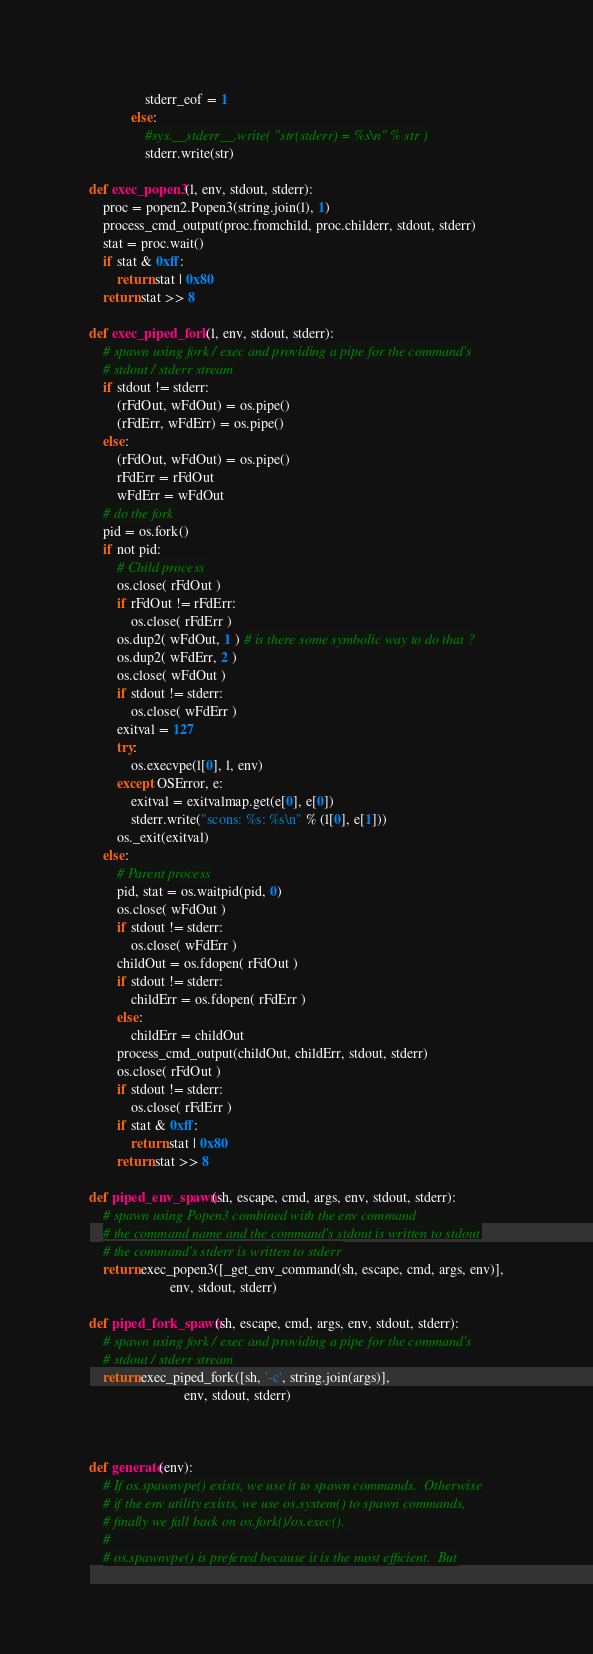<code> <loc_0><loc_0><loc_500><loc_500><_Python_>                stderr_eof = 1
            else:
                #sys.__stderr__.write( "str(stderr) = %s\n" % str )
                stderr.write(str)

def exec_popen3(l, env, stdout, stderr):
    proc = popen2.Popen3(string.join(l), 1)
    process_cmd_output(proc.fromchild, proc.childerr, stdout, stderr)
    stat = proc.wait()
    if stat & 0xff:
        return stat | 0x80
    return stat >> 8

def exec_piped_fork(l, env, stdout, stderr):
    # spawn using fork / exec and providing a pipe for the command's
    # stdout / stderr stream
    if stdout != stderr:
        (rFdOut, wFdOut) = os.pipe()
        (rFdErr, wFdErr) = os.pipe()
    else:
        (rFdOut, wFdOut) = os.pipe()
        rFdErr = rFdOut
        wFdErr = wFdOut
    # do the fork
    pid = os.fork()
    if not pid:
        # Child process
        os.close( rFdOut )
        if rFdOut != rFdErr:
            os.close( rFdErr )
        os.dup2( wFdOut, 1 ) # is there some symbolic way to do that ?
        os.dup2( wFdErr, 2 )
        os.close( wFdOut )
        if stdout != stderr:
            os.close( wFdErr )
        exitval = 127
        try:
            os.execvpe(l[0], l, env)
        except OSError, e:
            exitval = exitvalmap.get(e[0], e[0])
            stderr.write("scons: %s: %s\n" % (l[0], e[1]))
        os._exit(exitval)
    else:
        # Parent process
        pid, stat = os.waitpid(pid, 0)
        os.close( wFdOut )
        if stdout != stderr:
            os.close( wFdErr )
        childOut = os.fdopen( rFdOut )
        if stdout != stderr:
            childErr = os.fdopen( rFdErr )
        else:
            childErr = childOut
        process_cmd_output(childOut, childErr, stdout, stderr)
        os.close( rFdOut )
        if stdout != stderr:
            os.close( rFdErr )
        if stat & 0xff:
            return stat | 0x80
        return stat >> 8

def piped_env_spawn(sh, escape, cmd, args, env, stdout, stderr):
    # spawn using Popen3 combined with the env command
    # the command name and the command's stdout is written to stdout
    # the command's stderr is written to stderr
    return exec_popen3([_get_env_command(sh, escape, cmd, args, env)],
                       env, stdout, stderr)

def piped_fork_spawn(sh, escape, cmd, args, env, stdout, stderr):
    # spawn using fork / exec and providing a pipe for the command's
    # stdout / stderr stream
    return exec_piped_fork([sh, '-c', string.join(args)],
                           env, stdout, stderr)



def generate(env):
    # If os.spawnvpe() exists, we use it to spawn commands.  Otherwise
    # if the env utility exists, we use os.system() to spawn commands,
    # finally we fall back on os.fork()/os.exec().  
    #
    # os.spawnvpe() is prefered because it is the most efficient.  But</code> 